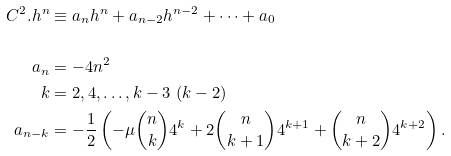<formula> <loc_0><loc_0><loc_500><loc_500>C ^ { 2 } . { h } ^ { n } & \equiv a _ { n } h ^ { n } + a _ { n - 2 } h ^ { n - 2 } + \cdots + a _ { 0 } \\ \\ a _ { n } & = - 4 n ^ { 2 } \\ k & = 2 , 4 , \dots , k - 3 \ ( k - 2 ) \\ a _ { n - k } & = - \frac { 1 } { 2 } \left ( - \mu { n \choose k } 4 ^ { k } + 2 { n \choose k + 1 } 4 ^ { k + 1 } + { n \choose k + 2 } 4 ^ { k + 2 } \right ) .</formula> 